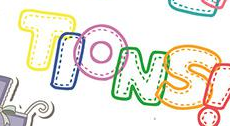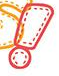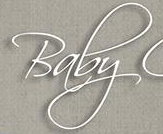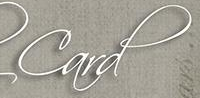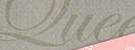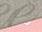What words can you see in these images in sequence, separated by a semicolon? TIONS; !; Baby; Card; Que; # 